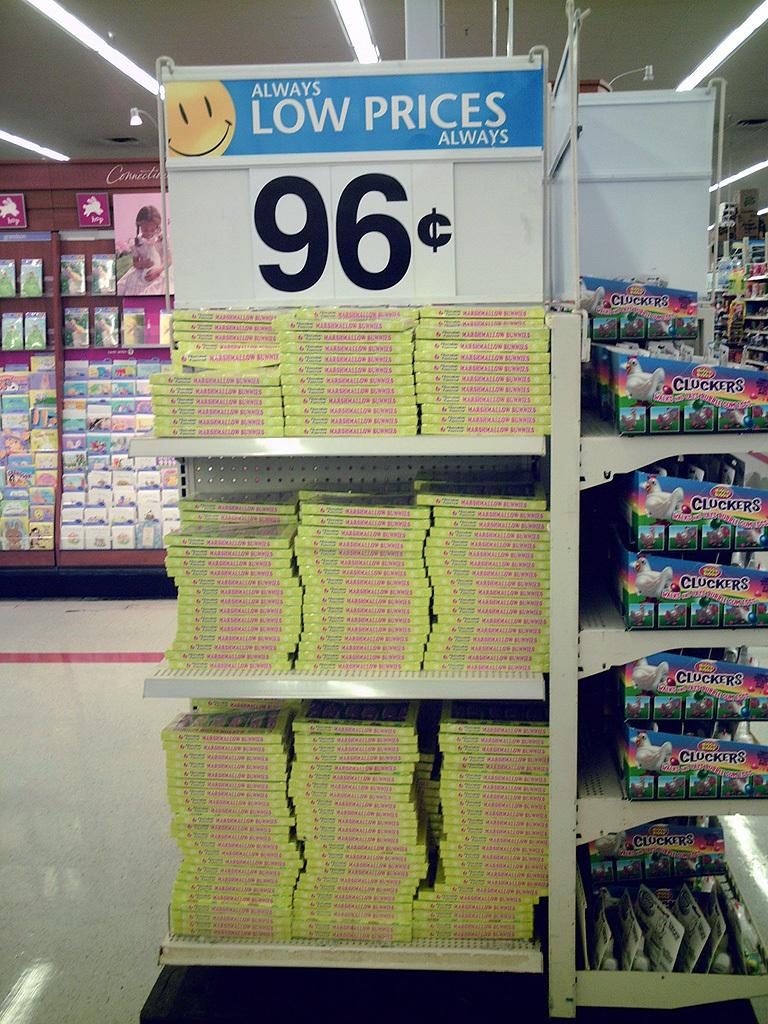<image>
Describe the image concisely. A Walmart display with a 96 cents sign on it. 